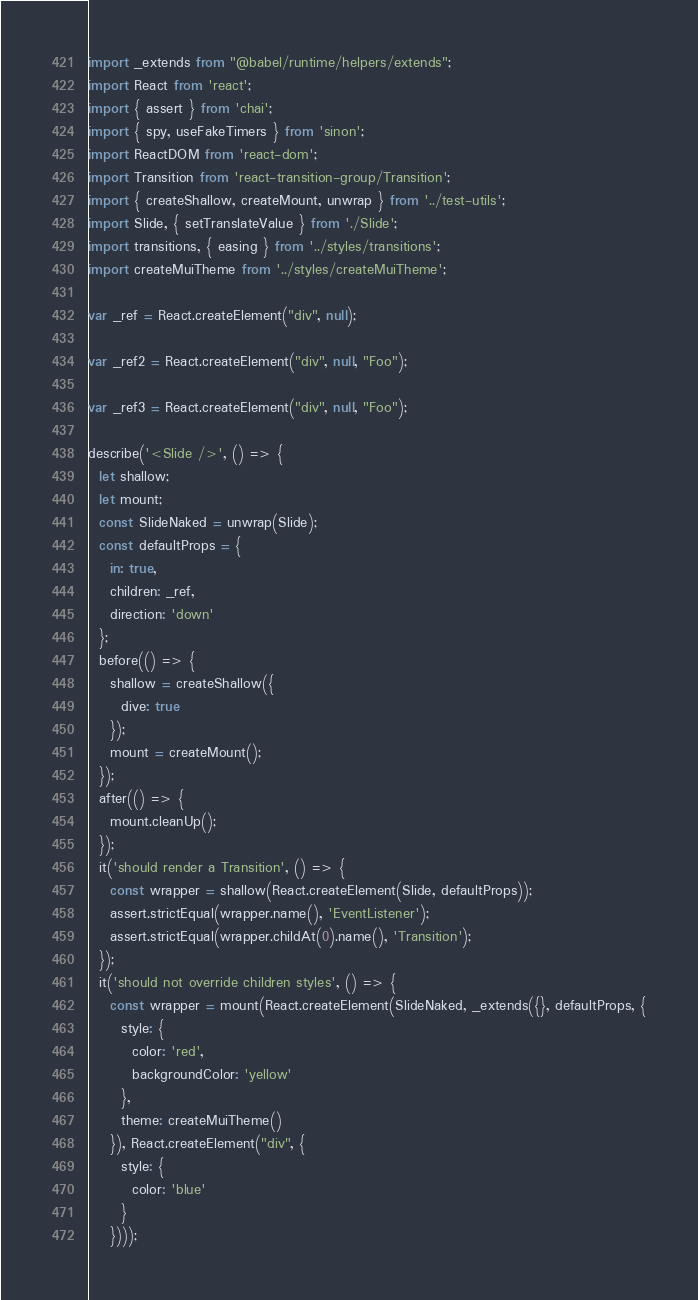Convert code to text. <code><loc_0><loc_0><loc_500><loc_500><_JavaScript_>import _extends from "@babel/runtime/helpers/extends";
import React from 'react';
import { assert } from 'chai';
import { spy, useFakeTimers } from 'sinon';
import ReactDOM from 'react-dom';
import Transition from 'react-transition-group/Transition';
import { createShallow, createMount, unwrap } from '../test-utils';
import Slide, { setTranslateValue } from './Slide';
import transitions, { easing } from '../styles/transitions';
import createMuiTheme from '../styles/createMuiTheme';

var _ref = React.createElement("div", null);

var _ref2 = React.createElement("div", null, "Foo");

var _ref3 = React.createElement("div", null, "Foo");

describe('<Slide />', () => {
  let shallow;
  let mount;
  const SlideNaked = unwrap(Slide);
  const defaultProps = {
    in: true,
    children: _ref,
    direction: 'down'
  };
  before(() => {
    shallow = createShallow({
      dive: true
    });
    mount = createMount();
  });
  after(() => {
    mount.cleanUp();
  });
  it('should render a Transition', () => {
    const wrapper = shallow(React.createElement(Slide, defaultProps));
    assert.strictEqual(wrapper.name(), 'EventListener');
    assert.strictEqual(wrapper.childAt(0).name(), 'Transition');
  });
  it('should not override children styles', () => {
    const wrapper = mount(React.createElement(SlideNaked, _extends({}, defaultProps, {
      style: {
        color: 'red',
        backgroundColor: 'yellow'
      },
      theme: createMuiTheme()
    }), React.createElement("div", {
      style: {
        color: 'blue'
      }
    })));</code> 